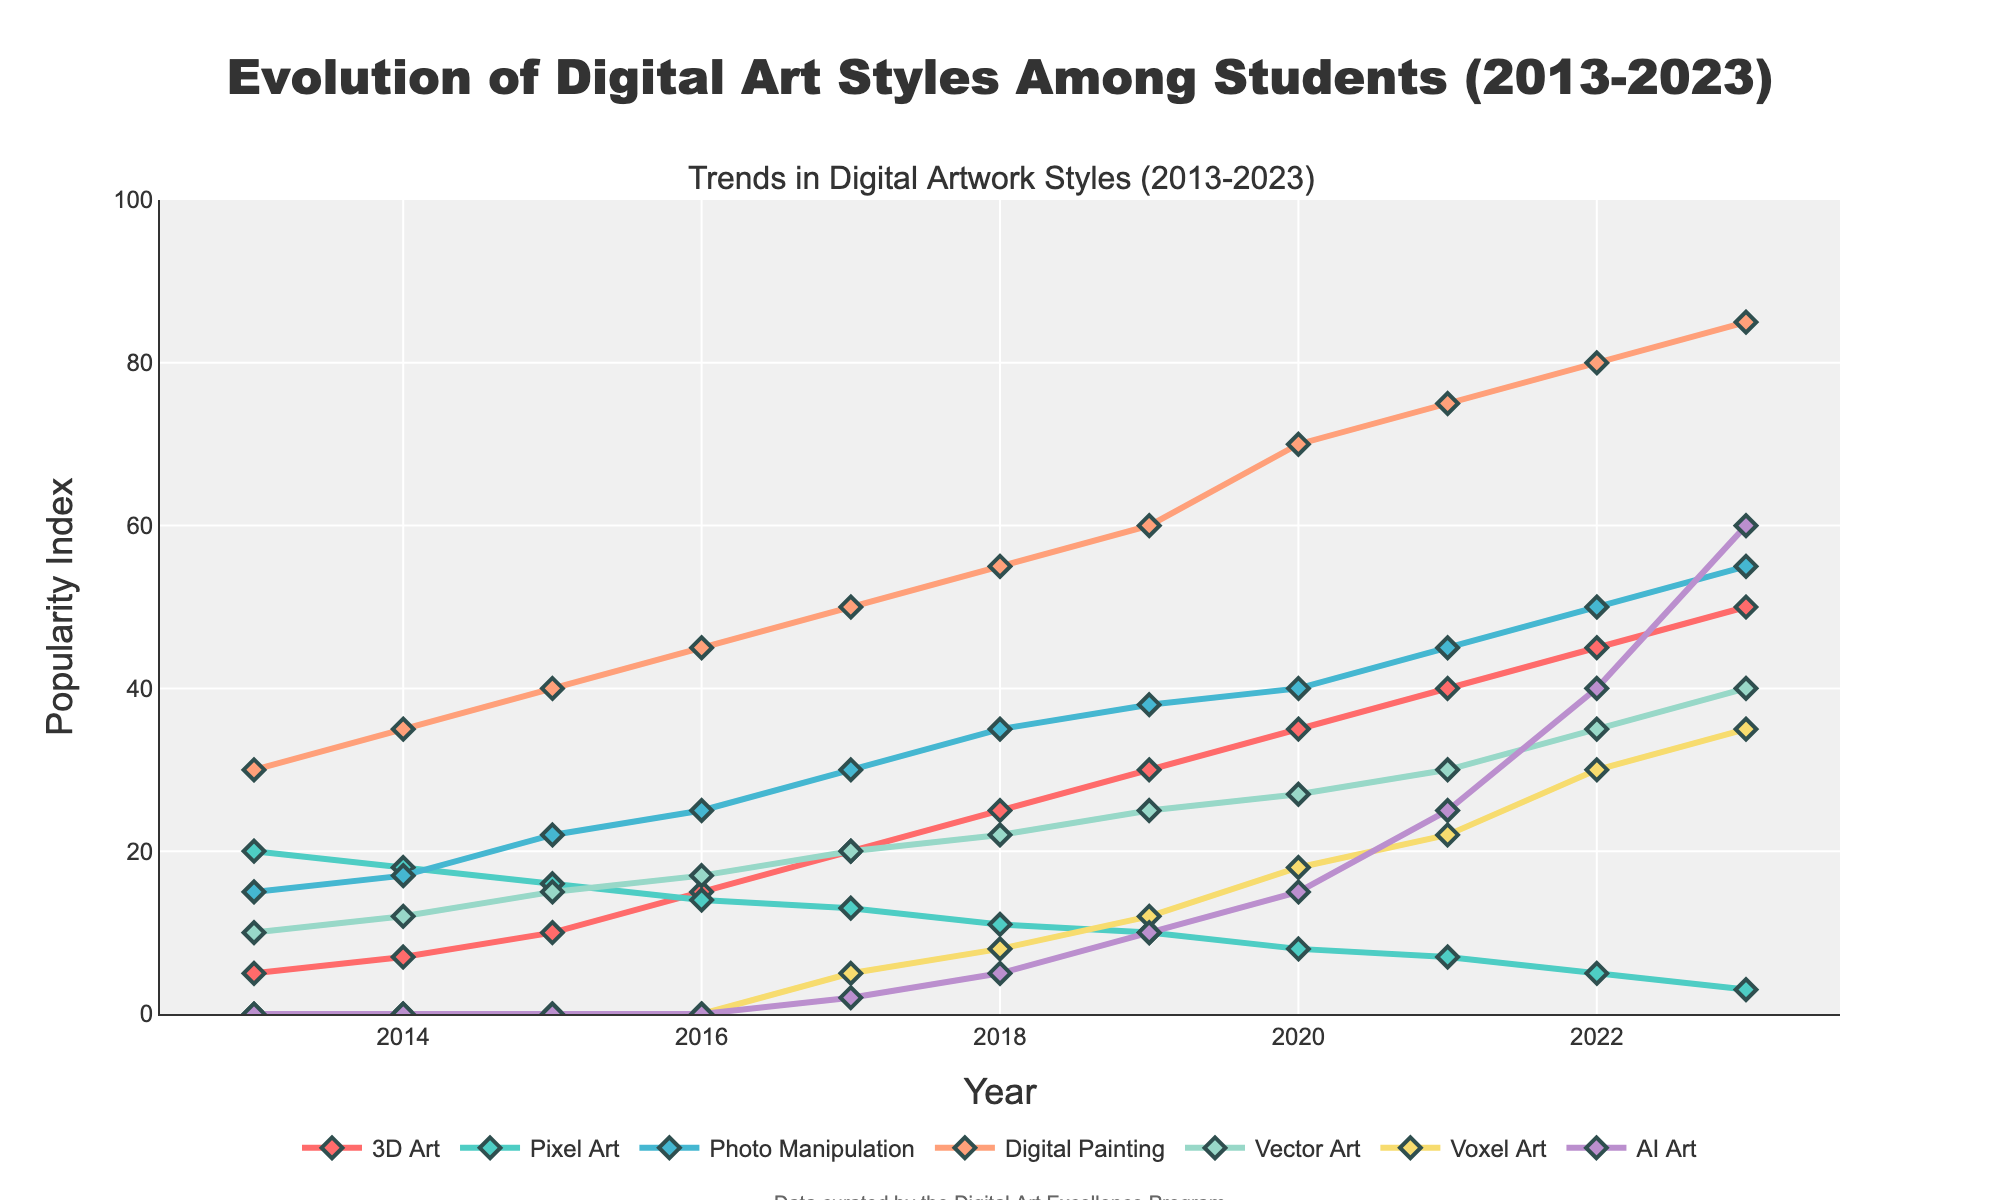what is the title of the figure? The title is usually located at the top of the figure. By reading the top section of the plot, you can find the title text presented prominently.
Answer: Evolution of Digital Art Styles Among Students (2013-2023) What year did AI Art first appear in the dataset? By examining the AI Art trend, we can identify the first year when its popularity index is higher than zero. The initial point appears in the year 2017.
Answer: 2017 Which art style had the highest popularity index in 2023? Look at the y-values for each style in the year 2023. Identify the highest y-value and associate it with the corresponding art style. Digital Painting reaches the highest value at 85.
Answer: Digital Painting How has the popularity of Pixel Art changed from 2013 to 2023? Observe the line representing Pixel Art from 2013 to 2023. The trend shows a gradual decrease from a value of 20 in 2013 to 3 in 2023.
Answer: Decreased Between which two years did 3D Art show the greatest increase in popularity? To determine the greatest increase, look at the changes in the y-values between consecutive years. Identify the pair of years with the highest difference. The most significant increase is from 2016 to 2017, where the index changed from 15 to 20.
Answer: 2016 to 2017 What is the combined popularity index of 3D Art and AI Art in 2023? Find the y-values for 3D Art and AI Art in 2023, then add them together. For 3D Art, it is 50, and for AI Art, it is 60. Adding these gives us 50 + 60 = 110.
Answer: 110 Which art style shows a consistent year-over-year increase throughout the entire period? Examine each trend line to find the one that shows incremental growth every year without any decreases. Digital Painting shows such a steady increase from 2013 to 2023.
Answer: Digital Painting In what year does Vector Art surpass 20 in popularity index? Follow the line for Vector Art and identify the first point where its y-value exceeds 20. This occurs in the year 2018.
Answer: 2018 